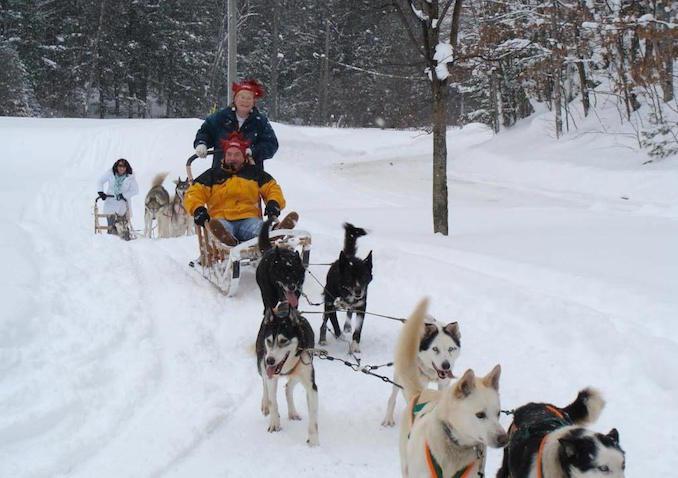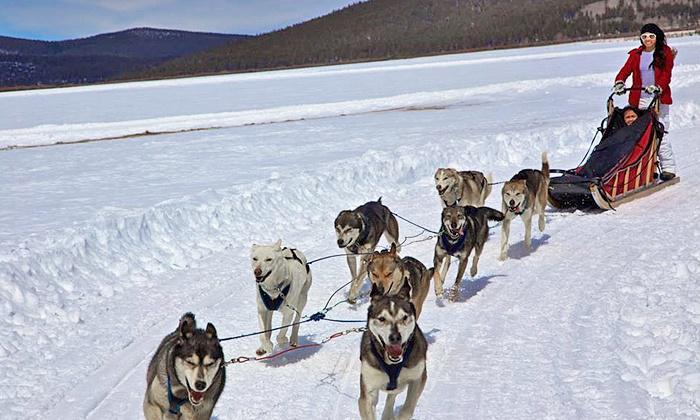The first image is the image on the left, the second image is the image on the right. For the images shown, is this caption "One image does not show a rider with a sled." true? Answer yes or no. No. The first image is the image on the left, the second image is the image on the right. For the images shown, is this caption "There is a person wearing red outerwear." true? Answer yes or no. Yes. 